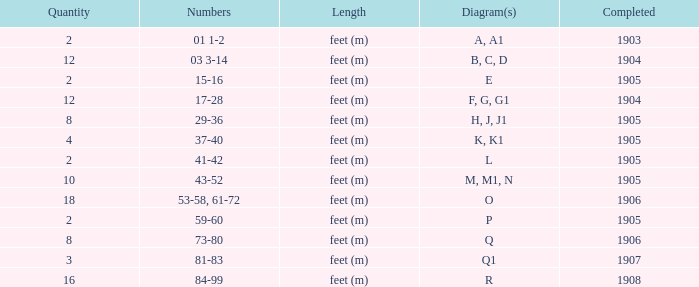What is the quantity of the item with the numbers of 29-36? 8.0. 